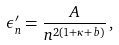<formula> <loc_0><loc_0><loc_500><loc_500>\epsilon _ { n } ^ { \prime } = \frac { A } { n ^ { 2 ( 1 + \kappa + b ) } } \, , \,</formula> 